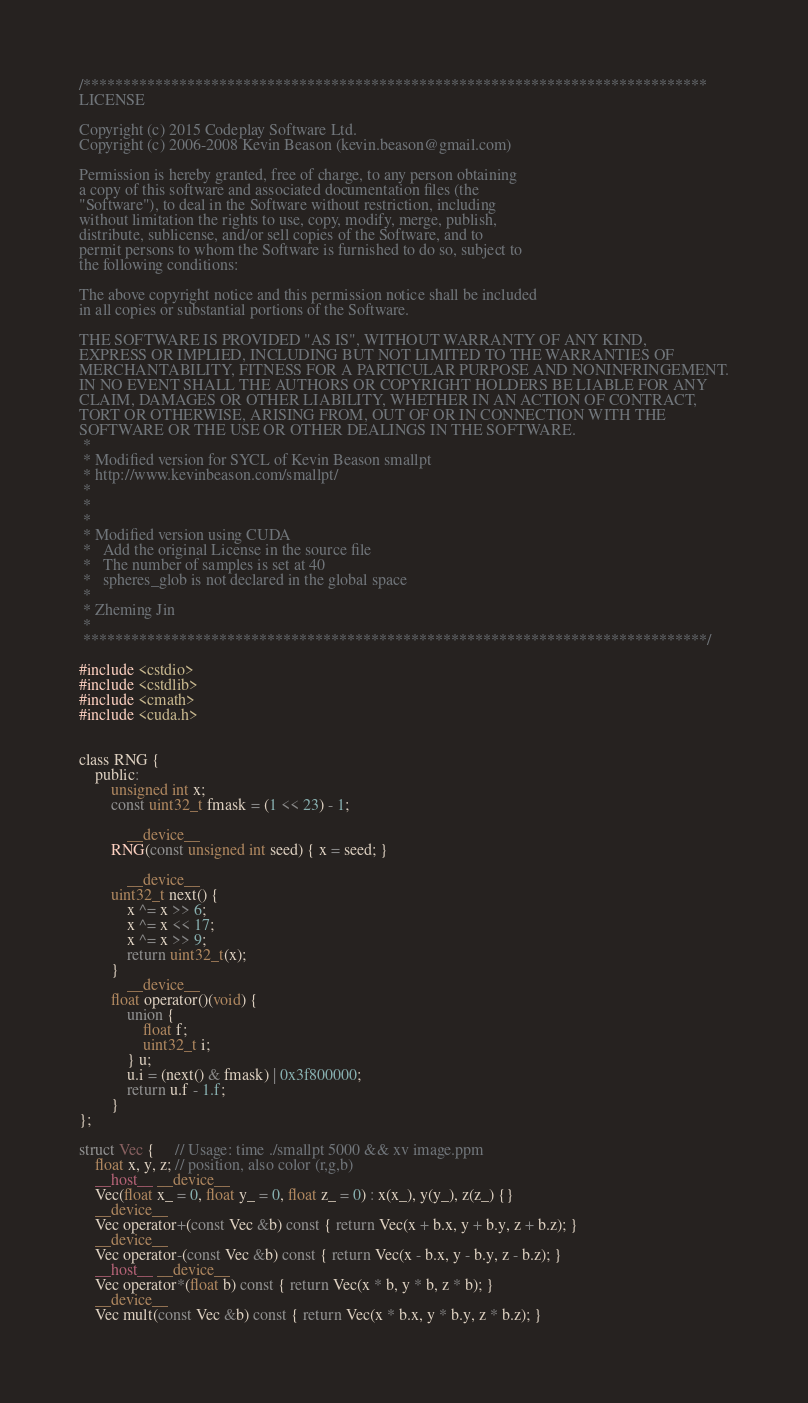Convert code to text. <code><loc_0><loc_0><loc_500><loc_500><_Cuda_>/******************************************************************************
LICENSE

Copyright (c) 2015 Codeplay Software Ltd.
Copyright (c) 2006-2008 Kevin Beason (kevin.beason@gmail.com)

Permission is hereby granted, free of charge, to any person obtaining
a copy of this software and associated documentation files (the
"Software"), to deal in the Software without restriction, including
without limitation the rights to use, copy, modify, merge, publish,
distribute, sublicense, and/or sell copies of the Software, and to
permit persons to whom the Software is furnished to do so, subject to
the following conditions:

The above copyright notice and this permission notice shall be included
in all copies or substantial portions of the Software.

THE SOFTWARE IS PROVIDED "AS IS", WITHOUT WARRANTY OF ANY KIND,
EXPRESS OR IMPLIED, INCLUDING BUT NOT LIMITED TO THE WARRANTIES OF
MERCHANTABILITY, FITNESS FOR A PARTICULAR PURPOSE AND NONINFRINGEMENT.
IN NO EVENT SHALL THE AUTHORS OR COPYRIGHT HOLDERS BE LIABLE FOR ANY
CLAIM, DAMAGES OR OTHER LIABILITY, WHETHER IN AN ACTION OF CONTRACT,
TORT OR OTHERWISE, ARISING FROM, OUT OF OR IN CONNECTION WITH THE
SOFTWARE OR THE USE OR OTHER DEALINGS IN THE SOFTWARE.
 *
 * Modified version for SYCL of Kevin Beason smallpt
 * http://www.kevinbeason.com/smallpt/
 *
 *
 *
 * Modified version using CUDA
 *   Add the original License in the source file
 *   The number of samples is set at 40
 *   spheres_glob is not declared in the global space
 *
 * Zheming Jin
 *
 ******************************************************************************/

#include <cstdio>
#include <cstdlib>
#include <cmath>
#include <cuda.h>


class RNG {
	public:
		unsigned int x;
		const uint32_t fmask = (1 << 23) - 1;

	        __device__
		RNG(const unsigned int seed) { x = seed; }

	        __device__
		uint32_t next() {
			x ^= x >> 6;
			x ^= x << 17;
			x ^= x >> 9;
			return uint32_t(x);
		}
	        __device__
		float operator()(void) {
			union {
				float f;
				uint32_t i;
			} u;
			u.i = (next() & fmask) | 0x3f800000;
			return u.f - 1.f;
		}
};

struct Vec {     // Usage: time ./smallpt 5000 && xv image.ppm
	float x, y, z; // position, also color (r,g,b)
	__host__ __device__
	Vec(float x_ = 0, float y_ = 0, float z_ = 0) : x(x_), y(y_), z(z_) {}
	__device__
	Vec operator+(const Vec &b) const { return Vec(x + b.x, y + b.y, z + b.z); }
	__device__
	Vec operator-(const Vec &b) const { return Vec(x - b.x, y - b.y, z - b.z); }
	__host__ __device__
	Vec operator*(float b) const { return Vec(x * b, y * b, z * b); }
	__device__
	Vec mult(const Vec &b) const { return Vec(x * b.x, y * b.y, z * b.z); }</code> 